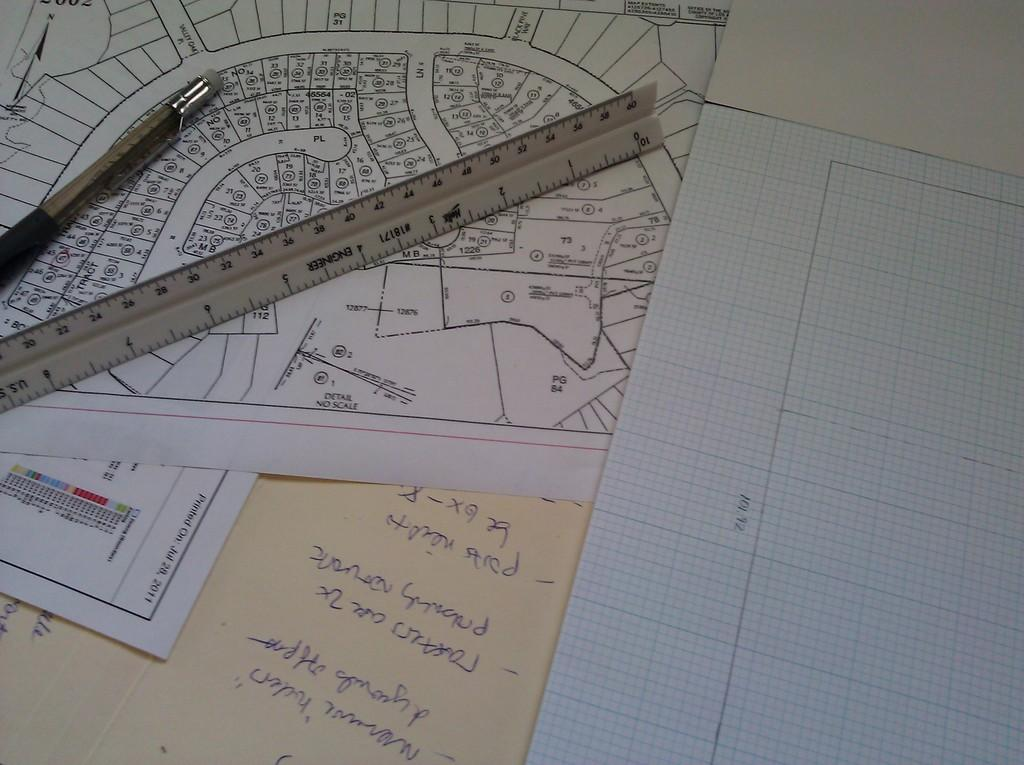<image>
Write a terse but informative summary of the picture. A ruler by the brand Engineer is on top of a drawing. 